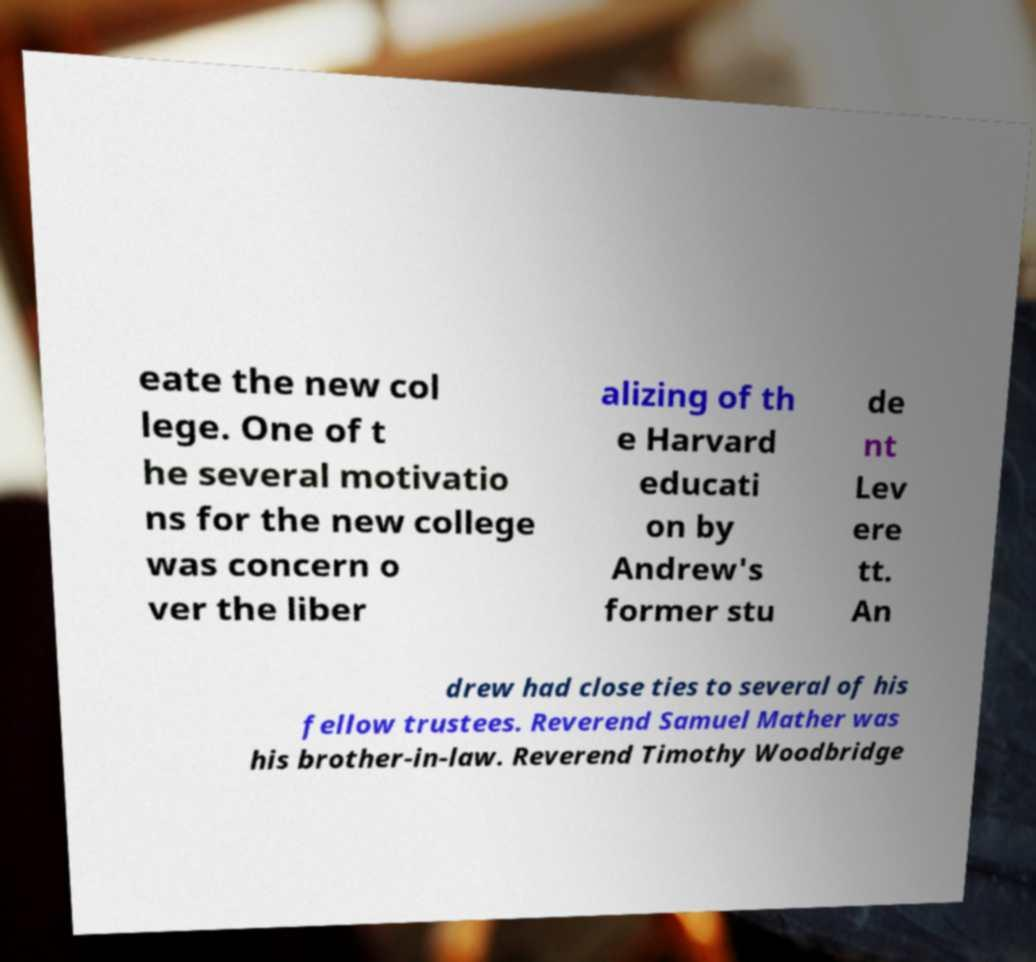Could you extract and type out the text from this image? eate the new col lege. One of t he several motivatio ns for the new college was concern o ver the liber alizing of th e Harvard educati on by Andrew's former stu de nt Lev ere tt. An drew had close ties to several of his fellow trustees. Reverend Samuel Mather was his brother-in-law. Reverend Timothy Woodbridge 